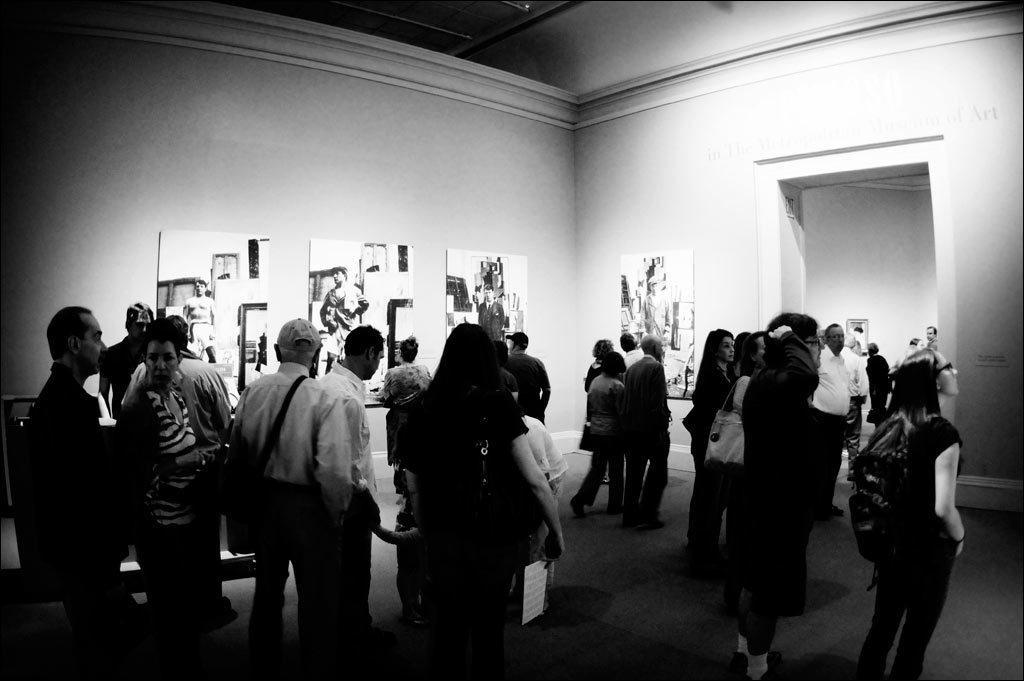In one or two sentences, can you explain what this image depicts? This is a black and white image and here we can see people and some are wearing bags and holding objects. In the background, there are boards on the wall. At the bottom, there is a floor. 